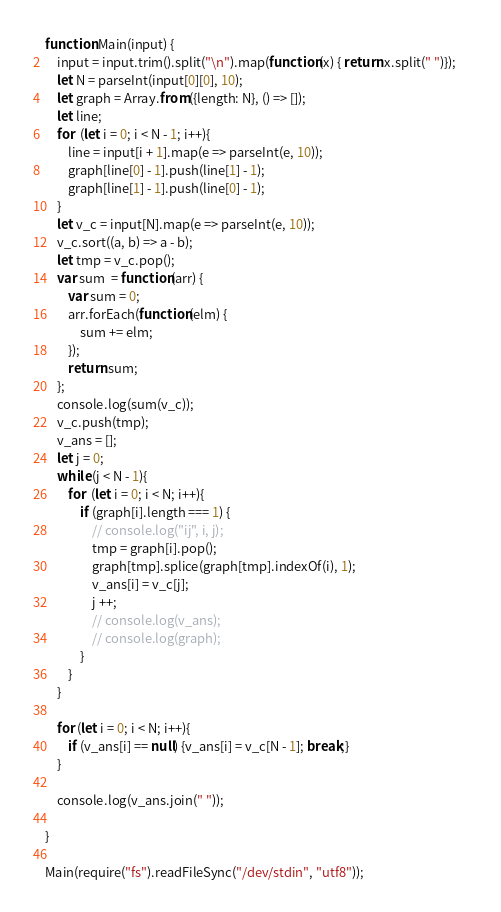<code> <loc_0><loc_0><loc_500><loc_500><_JavaScript_>function Main(input) {
	input = input.trim().split("\n").map(function(x) { return x.split(" ")});    
	let N = parseInt(input[0][0], 10);
	let graph = Array.from({length: N}, () => []);
	let line;
	for  (let i = 0; i < N - 1; i++){
		line = input[i + 1].map(e => parseInt(e, 10));
		graph[line[0] - 1].push(line[1] - 1);
		graph[line[1] - 1].push(line[0] - 1);
	}
	let v_c = input[N].map(e => parseInt(e, 10));
	v_c.sort((a, b) => a - b);
	let tmp = v_c.pop();
	var sum  = function(arr) {
		var sum = 0;
		arr.forEach(function(elm) {
			sum += elm;
		});
		return sum;
	};
	console.log(sum(v_c));
	v_c.push(tmp);
	v_ans = [];
	let j = 0;
	while (j < N - 1){
		for  (let i = 0; i < N; i++){
			if (graph[i].length === 1) {
				// console.log("ij", i, j);
				tmp = graph[i].pop();
				graph[tmp].splice(graph[tmp].indexOf(i), 1);
				v_ans[i] = v_c[j];
				j ++;
				// console.log(v_ans);
				// console.log(graph);
			}
		}
	}

	for (let i = 0; i < N; i++){
		if (v_ans[i] == null) {v_ans[i] = v_c[N - 1]; break;}
	}
	
	console.log(v_ans.join(" "));

}

Main(require("fs").readFileSync("/dev/stdin", "utf8"));


</code> 